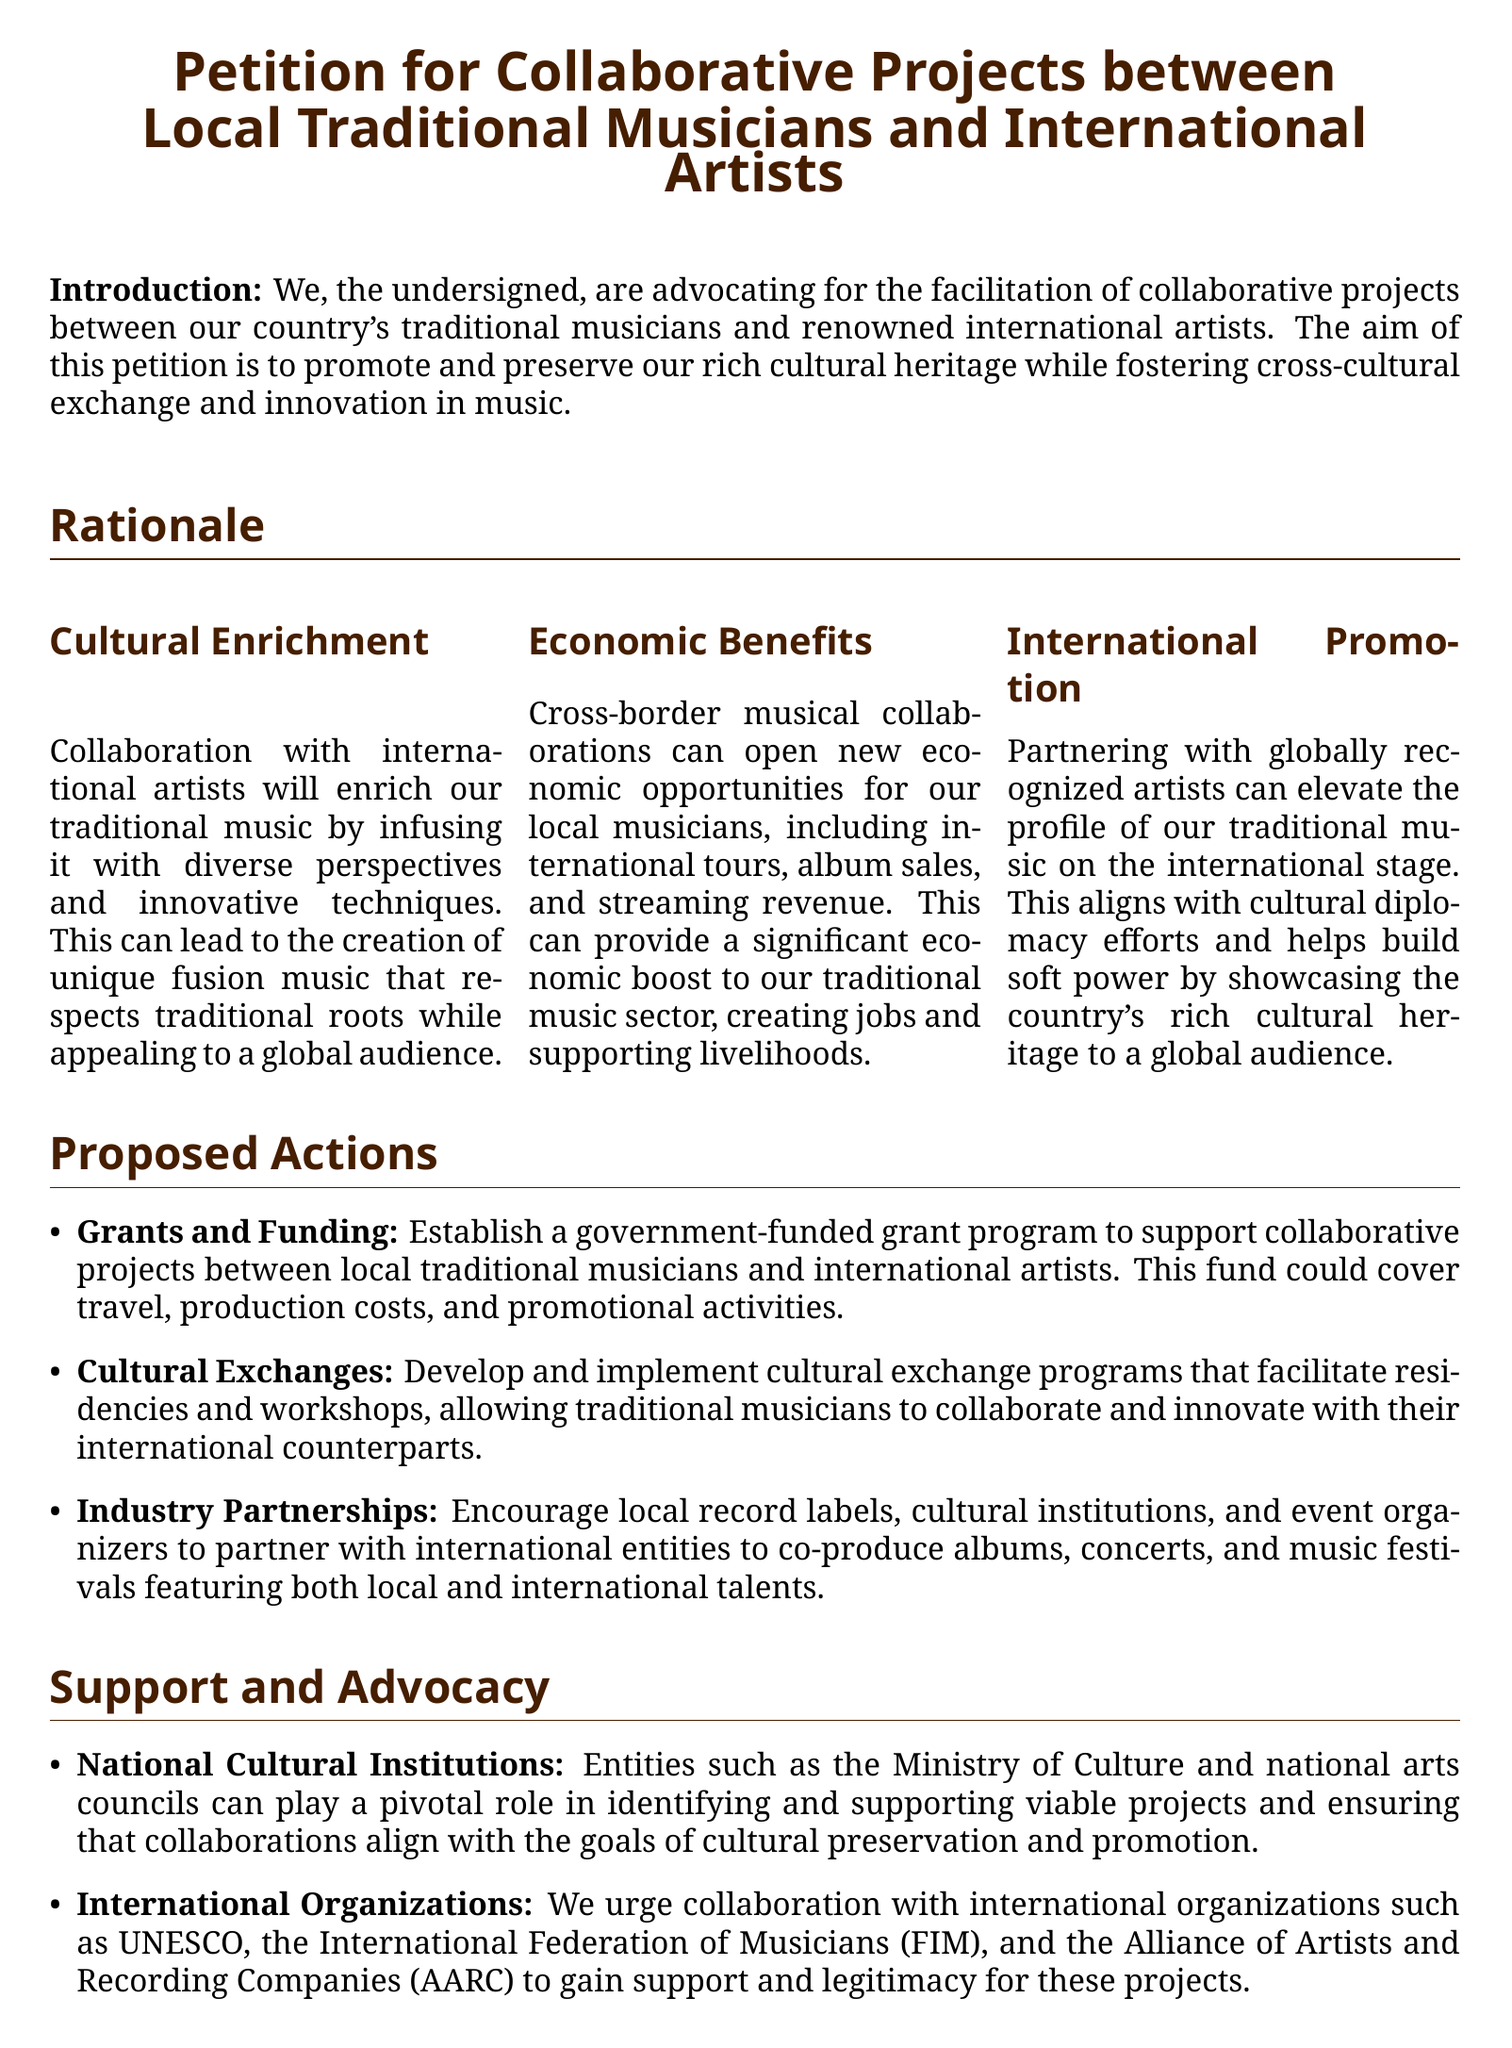What is the title of the petition? The title of the petition is stated at the beginning of the document.
Answer: Petition for Collaborative Projects between Local Traditional Musicians and International Artists Who can play a pivotal role in supporting viable projects? The section on support mentions national cultural institutions and their role in the petition.
Answer: National Cultural Institutions What economic opportunities are mentioned in the document? The document mentions several economic opportunities as a result of cross-border collaborations.
Answer: International tours, album sales, and streaming revenue What are the three proposed actions? The proposed actions are listed in a bullet format within the document.
Answer: Grants and Funding, Cultural Exchanges, Industry Partnerships What color is used for the page background? The document specifies a specific color for the page background.
Answer: White Which international organization is mentioned for collaboration? The document lists an international organization related to musicians.
Answer: UNESCO How does the petition aim to promote cultural heritage? The rationale section outlines the ultimate goal of the petition regarding cultural heritage.
Answer: By fostering cross-cultural exchange and innovation in music What type of music is the focus of the petition? The document specifically mentions the type of music the petition aims to support and promote.
Answer: Traditional music What is the significance of the signature space in the document? The signature space indicates the importance of public support and agreement with the petition.
Answer: It gathers support from signatories 